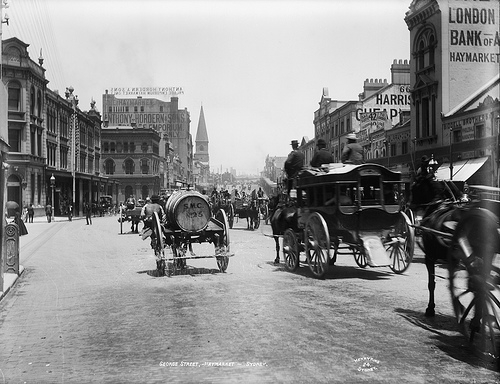Identify and read out the text in this image. 66 HARRIS P 42 SMC NTHONY MORDERN HAYMARKET BANK of LONDON 